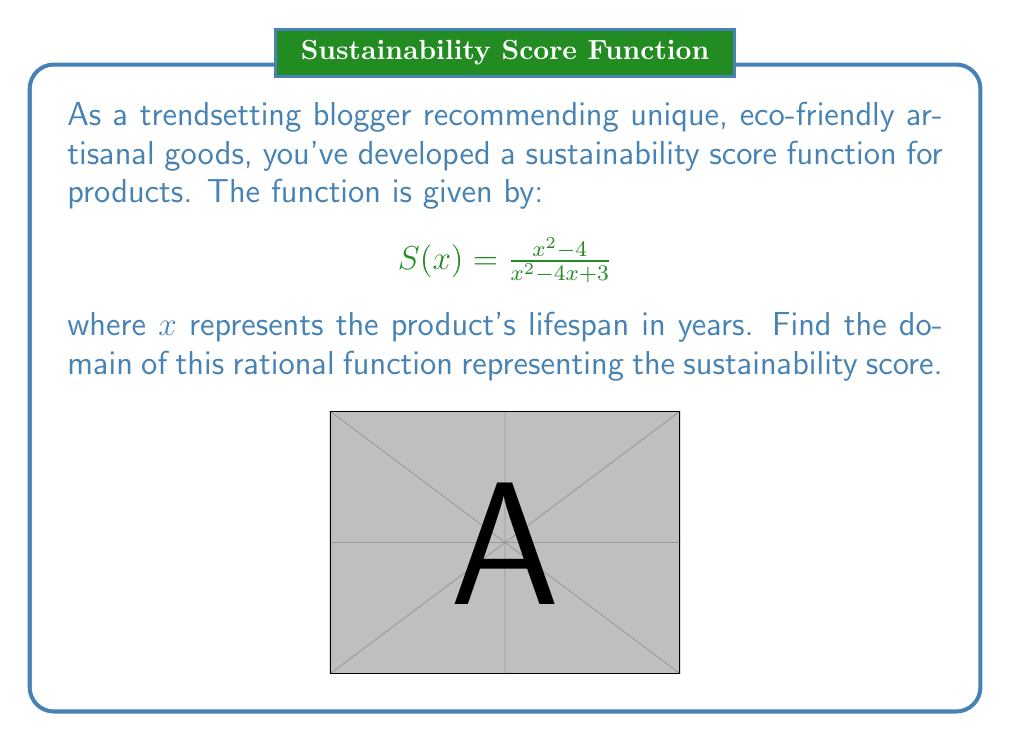Help me with this question. To find the domain of a rational function, we need to determine all real values of $x$ for which the function is defined. The function will be undefined when its denominator equals zero. Let's solve this step-by-step:

1) Set the denominator equal to zero:
   $x^2 - 4x + 3 = 0$

2) This is a quadratic equation. We can solve it using the quadratic formula:
   $x = \frac{-b \pm \sqrt{b^2 - 4ac}}{2a}$, where $a=1$, $b=-4$, and $c=3$

3) Substituting these values:
   $x = \frac{4 \pm \sqrt{16 - 12}}{2} = \frac{4 \pm \sqrt{4}}{2} = \frac{4 \pm 2}{2}$

4) This gives us two solutions:
   $x = \frac{4 + 2}{2} = 3$ or $x = \frac{4 - 2}{2} = 1$

5) The function will be undefined when $x = 1$ or $x = 3$

6) Therefore, the domain of the function is all real numbers except 1 and 3

In set notation, we write this as: $\{x \in \mathbb{R} : x \neq 1 \text{ and } x \neq 3\}$
Answer: $\{x \in \mathbb{R} : x \neq 1 \text{ and } x \neq 3\}$ 